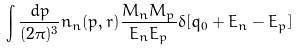<formula> <loc_0><loc_0><loc_500><loc_500>\int \frac { d p } { ( 2 \pi ) ^ { 3 } } { n _ { n } ( p , r ) } \frac { M _ { n } M _ { p } } { E _ { n } E _ { p } } \delta [ q _ { 0 } + E _ { n } - E _ { p } ]</formula> 